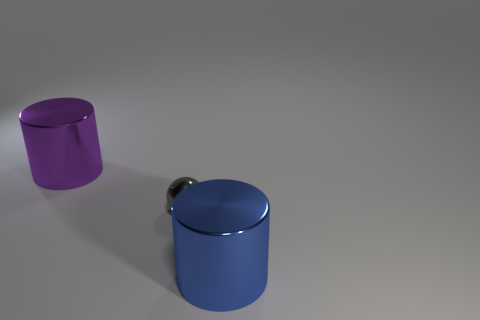There is another thing that is the same shape as the large blue metallic thing; what size is it?
Make the answer very short. Large. What is the size of the metal cylinder that is in front of the metallic ball?
Offer a very short reply. Large. Is the number of spheres behind the big purple cylinder greater than the number of big blue objects?
Provide a succinct answer. No. What is the shape of the large purple shiny thing?
Offer a terse response. Cylinder. Do the cylinder right of the purple metal object and the small metal object that is in front of the purple thing have the same color?
Keep it short and to the point. No. Does the big purple thing have the same shape as the small thing?
Offer a terse response. No. Are there any other things that have the same shape as the large purple object?
Ensure brevity in your answer.  Yes. Do the large object that is behind the small metal ball and the blue object have the same material?
Provide a short and direct response. Yes. There is a object that is behind the blue object and in front of the large purple metal cylinder; what is its shape?
Provide a short and direct response. Sphere. There is a big metallic object that is behind the large blue cylinder; is there a purple cylinder to the right of it?
Provide a succinct answer. No. 